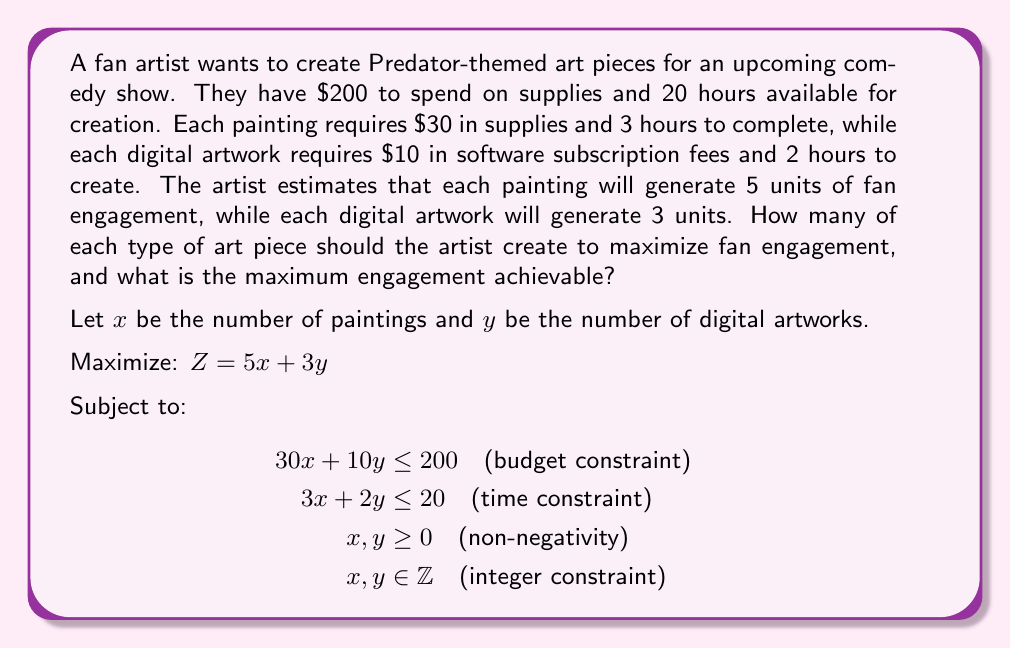Show me your answer to this math problem. To solve this integer linear programming problem, we'll use the graphical method and then check integer solutions:

1. Plot the constraints:
   - Budget: $30x + 10y = 200$ ⇒ $y = 20 - 3x$
   - Time: $3x + 2y = 20$ ⇒ $y = 10 - \frac{3}{2}x$

2. Find the feasible region:
   [asy]
   import geometry;
   
   size(200);
   
   real xmax = 7;
   real ymax = 10;
   
   draw((0,0)--(xmax,0)--(xmax,ymax)--(0,ymax)--cycle);
   
   draw((0,20)--(20/3,0), blue);
   draw((0,10)--(20/3,0), red);
   
   fill((0,10)--(20/3,0)--(0,0)--cycle, palegreen);
   
   label("Budget", (5,7), blue);
   label("Time", (4,5), red);
   label("Feasible Region", (2,3), darkgreen);
   
   xaxis("x", arrow=Arrow);
   yaxis("y", arrow=Arrow);
   
   dot((0,10));
   dot((20/3,0));
   dot((5,5));
   
   label("(0,10)", (0,10), W);
   label("(6.67,0)", (20/3,0), S);
   label("(5,5)", (5,5), NE);
   [/asy]

3. Identify corner points of the feasible region:
   (0,0), (0,10), (5,5), (6.67,0)

4. Evaluate the objective function at integer points near these corners:
   - (0,0): $Z = 0$
   - (0,10): $Z = 30$
   - (5,5): $Z = 40$
   - (6,0): $Z = 30$

5. The maximum integer solution is at (5,5) with $Z = 40$.

Therefore, the artist should create 5 paintings and 5 digital artworks to maximize fan engagement.
Answer: The artist should create 5 paintings and 5 digital artworks, achieving a maximum fan engagement of 40 units. 